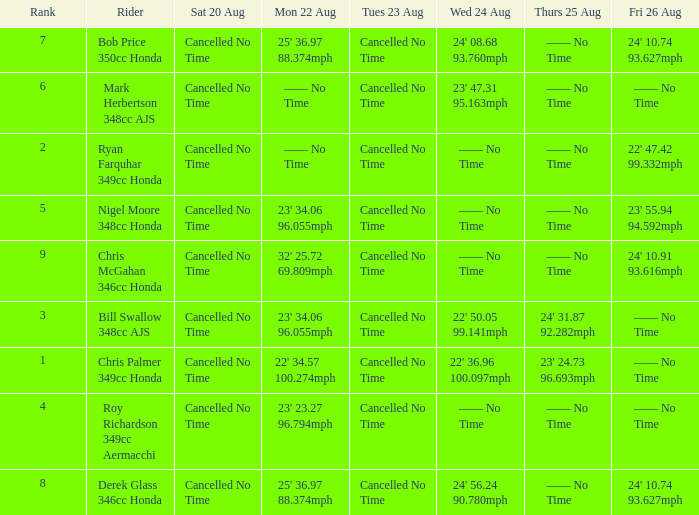What is every value on Thursday August 25 for rank 3? 24' 31.87 92.282mph. 